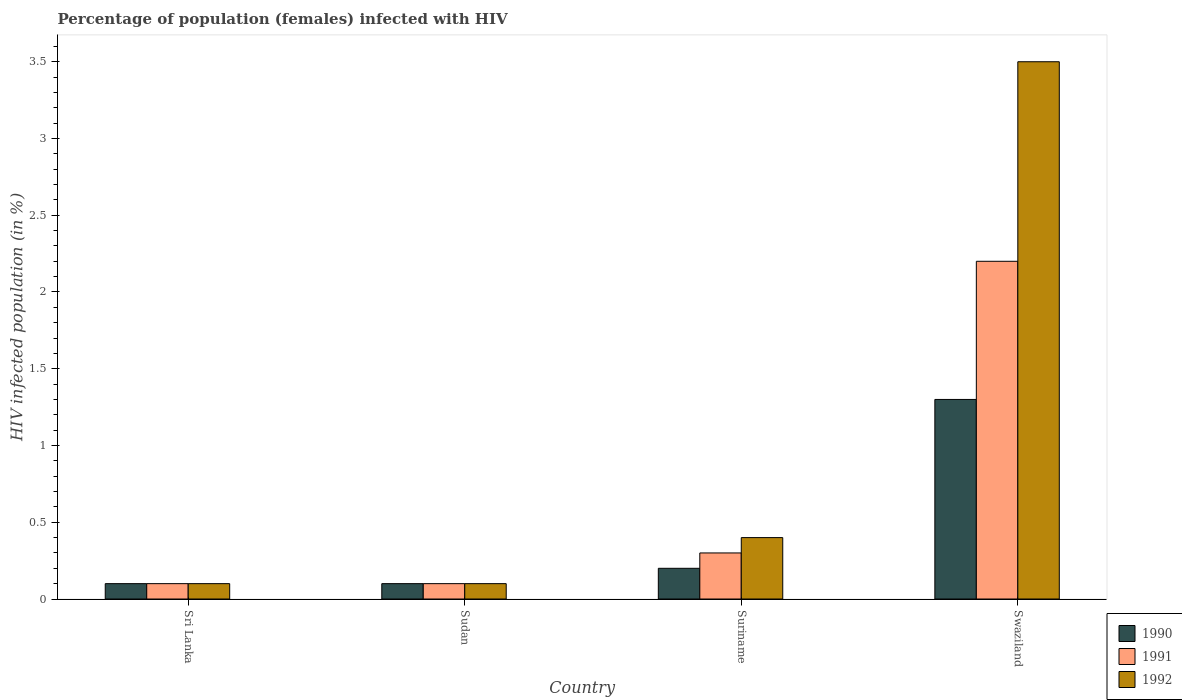Are the number of bars per tick equal to the number of legend labels?
Provide a short and direct response. Yes. What is the label of the 2nd group of bars from the left?
Your answer should be compact. Sudan. In how many cases, is the number of bars for a given country not equal to the number of legend labels?
Your answer should be compact. 0. What is the percentage of HIV infected female population in 1991 in Swaziland?
Keep it short and to the point. 2.2. Across all countries, what is the maximum percentage of HIV infected female population in 1991?
Provide a short and direct response. 2.2. In which country was the percentage of HIV infected female population in 1991 maximum?
Your response must be concise. Swaziland. In which country was the percentage of HIV infected female population in 1990 minimum?
Offer a very short reply. Sri Lanka. What is the total percentage of HIV infected female population in 1990 in the graph?
Provide a short and direct response. 1.7. What is the difference between the percentage of HIV infected female population in 1992 in Suriname and that in Swaziland?
Ensure brevity in your answer.  -3.1. What is the difference between the percentage of HIV infected female population in 1991 in Sri Lanka and the percentage of HIV infected female population in 1990 in Suriname?
Give a very brief answer. -0.1. What is the difference between the percentage of HIV infected female population of/in 1992 and percentage of HIV infected female population of/in 1991 in Sri Lanka?
Offer a very short reply. 0. What is the ratio of the percentage of HIV infected female population in 1991 in Sri Lanka to that in Suriname?
Give a very brief answer. 0.33. What is the difference between the highest and the second highest percentage of HIV infected female population in 1991?
Provide a short and direct response. -1.9. In how many countries, is the percentage of HIV infected female population in 1992 greater than the average percentage of HIV infected female population in 1992 taken over all countries?
Make the answer very short. 1. What does the 3rd bar from the right in Sri Lanka represents?
Your answer should be compact. 1990. How many countries are there in the graph?
Offer a terse response. 4. What is the difference between two consecutive major ticks on the Y-axis?
Offer a very short reply. 0.5. Does the graph contain any zero values?
Ensure brevity in your answer.  No. Where does the legend appear in the graph?
Ensure brevity in your answer.  Bottom right. How many legend labels are there?
Provide a short and direct response. 3. How are the legend labels stacked?
Provide a short and direct response. Vertical. What is the title of the graph?
Make the answer very short. Percentage of population (females) infected with HIV. Does "2000" appear as one of the legend labels in the graph?
Your answer should be compact. No. What is the label or title of the X-axis?
Keep it short and to the point. Country. What is the label or title of the Y-axis?
Provide a succinct answer. HIV infected population (in %). What is the HIV infected population (in %) of 1990 in Sri Lanka?
Give a very brief answer. 0.1. What is the HIV infected population (in %) of 1991 in Sri Lanka?
Give a very brief answer. 0.1. What is the HIV infected population (in %) of 1992 in Sri Lanka?
Ensure brevity in your answer.  0.1. What is the HIV infected population (in %) in 1990 in Sudan?
Offer a terse response. 0.1. What is the HIV infected population (in %) in 1991 in Sudan?
Offer a very short reply. 0.1. What is the HIV infected population (in %) of 1990 in Suriname?
Ensure brevity in your answer.  0.2. What is the HIV infected population (in %) of 1992 in Suriname?
Provide a succinct answer. 0.4. What is the HIV infected population (in %) in 1990 in Swaziland?
Provide a succinct answer. 1.3. Across all countries, what is the maximum HIV infected population (in %) of 1990?
Make the answer very short. 1.3. Across all countries, what is the minimum HIV infected population (in %) in 1990?
Give a very brief answer. 0.1. Across all countries, what is the minimum HIV infected population (in %) of 1991?
Provide a short and direct response. 0.1. Across all countries, what is the minimum HIV infected population (in %) in 1992?
Give a very brief answer. 0.1. What is the total HIV infected population (in %) of 1992 in the graph?
Your answer should be very brief. 4.1. What is the difference between the HIV infected population (in %) of 1990 in Sri Lanka and that in Sudan?
Provide a succinct answer. 0. What is the difference between the HIV infected population (in %) of 1992 in Sri Lanka and that in Sudan?
Give a very brief answer. 0. What is the difference between the HIV infected population (in %) of 1991 in Sri Lanka and that in Suriname?
Provide a succinct answer. -0.2. What is the difference between the HIV infected population (in %) of 1992 in Sri Lanka and that in Suriname?
Provide a succinct answer. -0.3. What is the difference between the HIV infected population (in %) of 1990 in Sudan and that in Suriname?
Offer a terse response. -0.1. What is the difference between the HIV infected population (in %) of 1992 in Sudan and that in Suriname?
Give a very brief answer. -0.3. What is the difference between the HIV infected population (in %) of 1990 in Sudan and that in Swaziland?
Your answer should be very brief. -1.2. What is the difference between the HIV infected population (in %) of 1992 in Sudan and that in Swaziland?
Your response must be concise. -3.4. What is the difference between the HIV infected population (in %) in 1992 in Suriname and that in Swaziland?
Provide a succinct answer. -3.1. What is the difference between the HIV infected population (in %) of 1990 in Sri Lanka and the HIV infected population (in %) of 1992 in Sudan?
Provide a succinct answer. 0. What is the difference between the HIV infected population (in %) of 1991 in Sri Lanka and the HIV infected population (in %) of 1992 in Sudan?
Give a very brief answer. 0. What is the difference between the HIV infected population (in %) of 1990 in Sri Lanka and the HIV infected population (in %) of 1992 in Suriname?
Offer a terse response. -0.3. What is the difference between the HIV infected population (in %) in 1990 in Sri Lanka and the HIV infected population (in %) in 1992 in Swaziland?
Your answer should be compact. -3.4. What is the difference between the HIV infected population (in %) of 1990 in Sudan and the HIV infected population (in %) of 1991 in Suriname?
Provide a succinct answer. -0.2. What is the difference between the HIV infected population (in %) in 1990 in Sudan and the HIV infected population (in %) in 1991 in Swaziland?
Your response must be concise. -2.1. What is the difference between the HIV infected population (in %) in 1990 in Sudan and the HIV infected population (in %) in 1992 in Swaziland?
Make the answer very short. -3.4. What is the average HIV infected population (in %) of 1990 per country?
Offer a terse response. 0.42. What is the average HIV infected population (in %) in 1991 per country?
Your answer should be very brief. 0.68. What is the difference between the HIV infected population (in %) in 1990 and HIV infected population (in %) in 1991 in Sri Lanka?
Keep it short and to the point. 0. What is the difference between the HIV infected population (in %) in 1990 and HIV infected population (in %) in 1991 in Sudan?
Provide a succinct answer. 0. What is the difference between the HIV infected population (in %) in 1991 and HIV infected population (in %) in 1992 in Sudan?
Provide a short and direct response. 0. What is the difference between the HIV infected population (in %) of 1990 and HIV infected population (in %) of 1992 in Swaziland?
Keep it short and to the point. -2.2. What is the ratio of the HIV infected population (in %) of 1990 in Sri Lanka to that in Sudan?
Ensure brevity in your answer.  1. What is the ratio of the HIV infected population (in %) of 1990 in Sri Lanka to that in Suriname?
Your response must be concise. 0.5. What is the ratio of the HIV infected population (in %) of 1991 in Sri Lanka to that in Suriname?
Offer a very short reply. 0.33. What is the ratio of the HIV infected population (in %) of 1992 in Sri Lanka to that in Suriname?
Your answer should be compact. 0.25. What is the ratio of the HIV infected population (in %) of 1990 in Sri Lanka to that in Swaziland?
Offer a very short reply. 0.08. What is the ratio of the HIV infected population (in %) of 1991 in Sri Lanka to that in Swaziland?
Your answer should be very brief. 0.05. What is the ratio of the HIV infected population (in %) in 1992 in Sri Lanka to that in Swaziland?
Your answer should be very brief. 0.03. What is the ratio of the HIV infected population (in %) of 1991 in Sudan to that in Suriname?
Ensure brevity in your answer.  0.33. What is the ratio of the HIV infected population (in %) of 1990 in Sudan to that in Swaziland?
Your answer should be very brief. 0.08. What is the ratio of the HIV infected population (in %) of 1991 in Sudan to that in Swaziland?
Provide a succinct answer. 0.05. What is the ratio of the HIV infected population (in %) of 1992 in Sudan to that in Swaziland?
Provide a succinct answer. 0.03. What is the ratio of the HIV infected population (in %) of 1990 in Suriname to that in Swaziland?
Your response must be concise. 0.15. What is the ratio of the HIV infected population (in %) of 1991 in Suriname to that in Swaziland?
Your answer should be very brief. 0.14. What is the ratio of the HIV infected population (in %) of 1992 in Suriname to that in Swaziland?
Keep it short and to the point. 0.11. What is the difference between the highest and the second highest HIV infected population (in %) of 1991?
Give a very brief answer. 1.9. What is the difference between the highest and the lowest HIV infected population (in %) in 1990?
Offer a very short reply. 1.2. What is the difference between the highest and the lowest HIV infected population (in %) in 1991?
Your answer should be very brief. 2.1. What is the difference between the highest and the lowest HIV infected population (in %) in 1992?
Your answer should be compact. 3.4. 